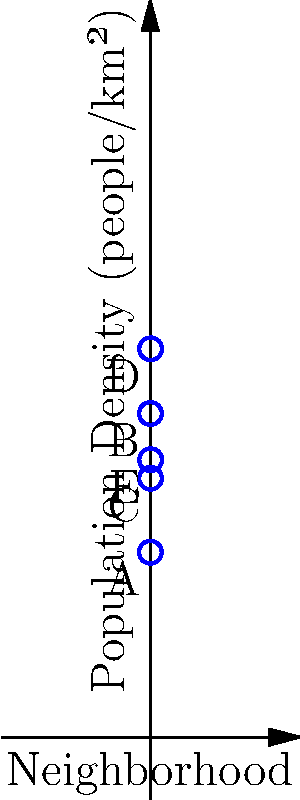The graph shows the population density of five neighborhoods (A, B, C, D, and E) in a city. If the urban planning department wants to focus on areas with high population density for infrastructure improvements, which two neighborhoods should they prioritize? Calculate the average population density of these two neighborhoods. To solve this problem, we need to follow these steps:

1. Identify the two neighborhoods with the highest population density:
   - Neighborhood A: 2000 people/km²
   - Neighborhood B: 3500 people/km²
   - Neighborhood C: 2800 people/km²
   - Neighborhood D: 4200 people/km²
   - Neighborhood E: 3000 people/km²

   The two highest are D (4200 people/km²) and B (3500 people/km²).

2. Calculate the average population density of these two neighborhoods:
   $$ \text{Average} = \frac{\text{Density}_D + \text{Density}_B}{2} $$
   $$ \text{Average} = \frac{4200 + 3500}{2} = \frac{7700}{2} = 3850 \text{ people/km²} $$

Therefore, the urban planning department should prioritize neighborhoods D and B, and the average population density of these two neighborhoods is 3850 people/km².
Answer: Neighborhoods D and B; 3850 people/km² 